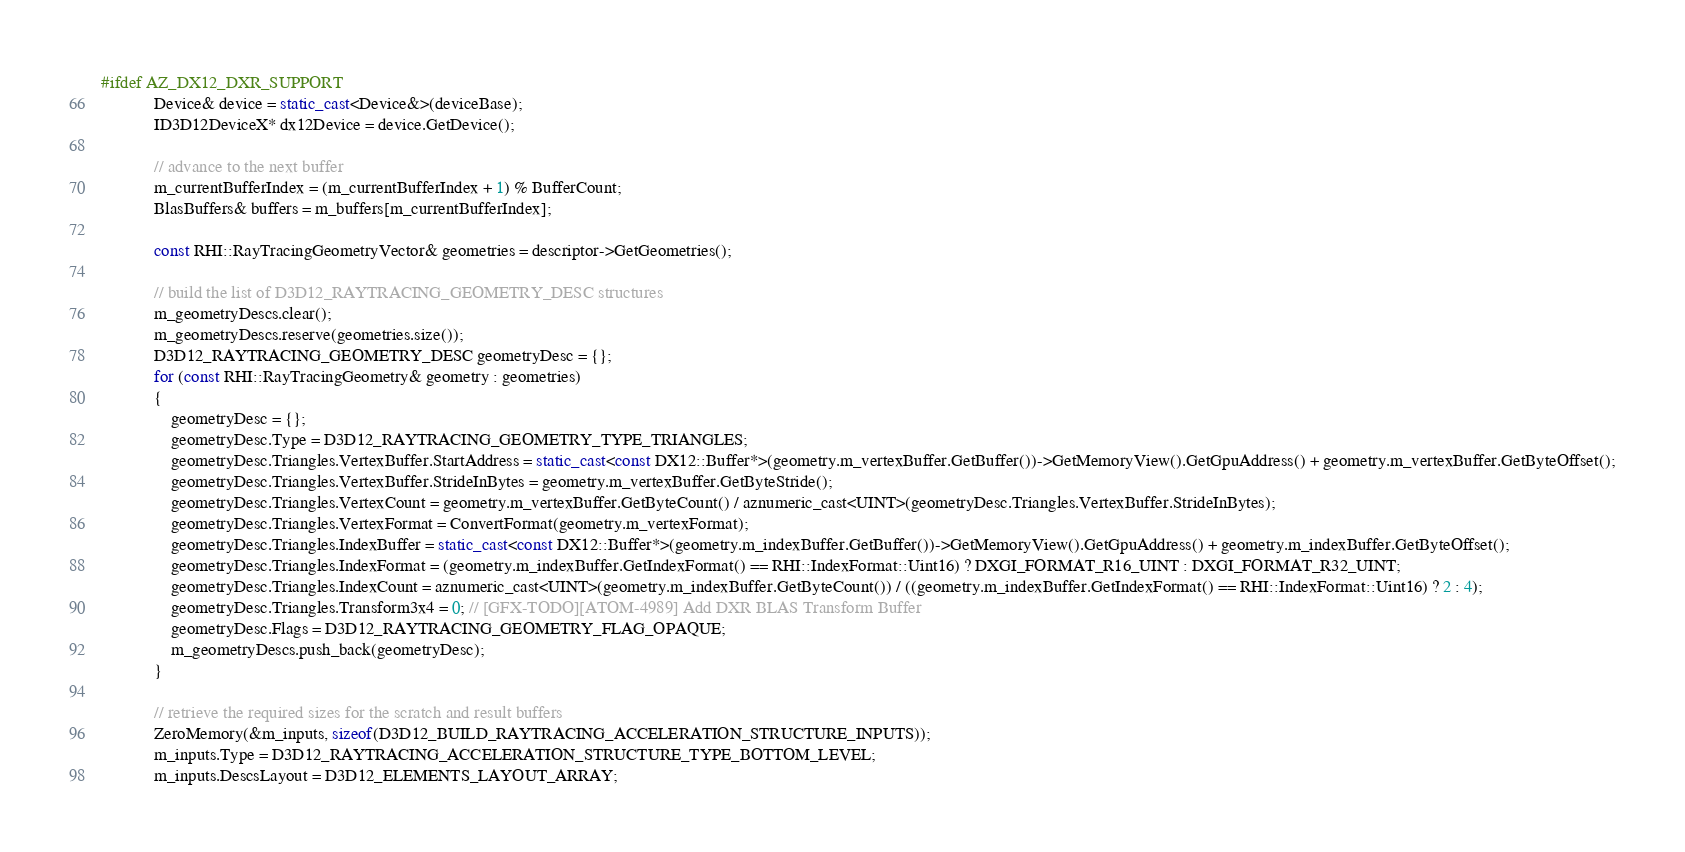<code> <loc_0><loc_0><loc_500><loc_500><_C++_>#ifdef AZ_DX12_DXR_SUPPORT
            Device& device = static_cast<Device&>(deviceBase);
            ID3D12DeviceX* dx12Device = device.GetDevice();

            // advance to the next buffer
            m_currentBufferIndex = (m_currentBufferIndex + 1) % BufferCount;
            BlasBuffers& buffers = m_buffers[m_currentBufferIndex];

            const RHI::RayTracingGeometryVector& geometries = descriptor->GetGeometries();

            // build the list of D3D12_RAYTRACING_GEOMETRY_DESC structures
            m_geometryDescs.clear();
            m_geometryDescs.reserve(geometries.size());
            D3D12_RAYTRACING_GEOMETRY_DESC geometryDesc = {};
            for (const RHI::RayTracingGeometry& geometry : geometries)
            {
                geometryDesc = {};
                geometryDesc.Type = D3D12_RAYTRACING_GEOMETRY_TYPE_TRIANGLES;
                geometryDesc.Triangles.VertexBuffer.StartAddress = static_cast<const DX12::Buffer*>(geometry.m_vertexBuffer.GetBuffer())->GetMemoryView().GetGpuAddress() + geometry.m_vertexBuffer.GetByteOffset();
                geometryDesc.Triangles.VertexBuffer.StrideInBytes = geometry.m_vertexBuffer.GetByteStride();
                geometryDesc.Triangles.VertexCount = geometry.m_vertexBuffer.GetByteCount() / aznumeric_cast<UINT>(geometryDesc.Triangles.VertexBuffer.StrideInBytes);
                geometryDesc.Triangles.VertexFormat = ConvertFormat(geometry.m_vertexFormat);
                geometryDesc.Triangles.IndexBuffer = static_cast<const DX12::Buffer*>(geometry.m_indexBuffer.GetBuffer())->GetMemoryView().GetGpuAddress() + geometry.m_indexBuffer.GetByteOffset();
                geometryDesc.Triangles.IndexFormat = (geometry.m_indexBuffer.GetIndexFormat() == RHI::IndexFormat::Uint16) ? DXGI_FORMAT_R16_UINT : DXGI_FORMAT_R32_UINT;
                geometryDesc.Triangles.IndexCount = aznumeric_cast<UINT>(geometry.m_indexBuffer.GetByteCount()) / ((geometry.m_indexBuffer.GetIndexFormat() == RHI::IndexFormat::Uint16) ? 2 : 4);
                geometryDesc.Triangles.Transform3x4 = 0; // [GFX-TODO][ATOM-4989] Add DXR BLAS Transform Buffer
                geometryDesc.Flags = D3D12_RAYTRACING_GEOMETRY_FLAG_OPAQUE;
                m_geometryDescs.push_back(geometryDesc);
            }

            // retrieve the required sizes for the scratch and result buffers            
            ZeroMemory(&m_inputs, sizeof(D3D12_BUILD_RAYTRACING_ACCELERATION_STRUCTURE_INPUTS));
            m_inputs.Type = D3D12_RAYTRACING_ACCELERATION_STRUCTURE_TYPE_BOTTOM_LEVEL;
            m_inputs.DescsLayout = D3D12_ELEMENTS_LAYOUT_ARRAY;</code> 